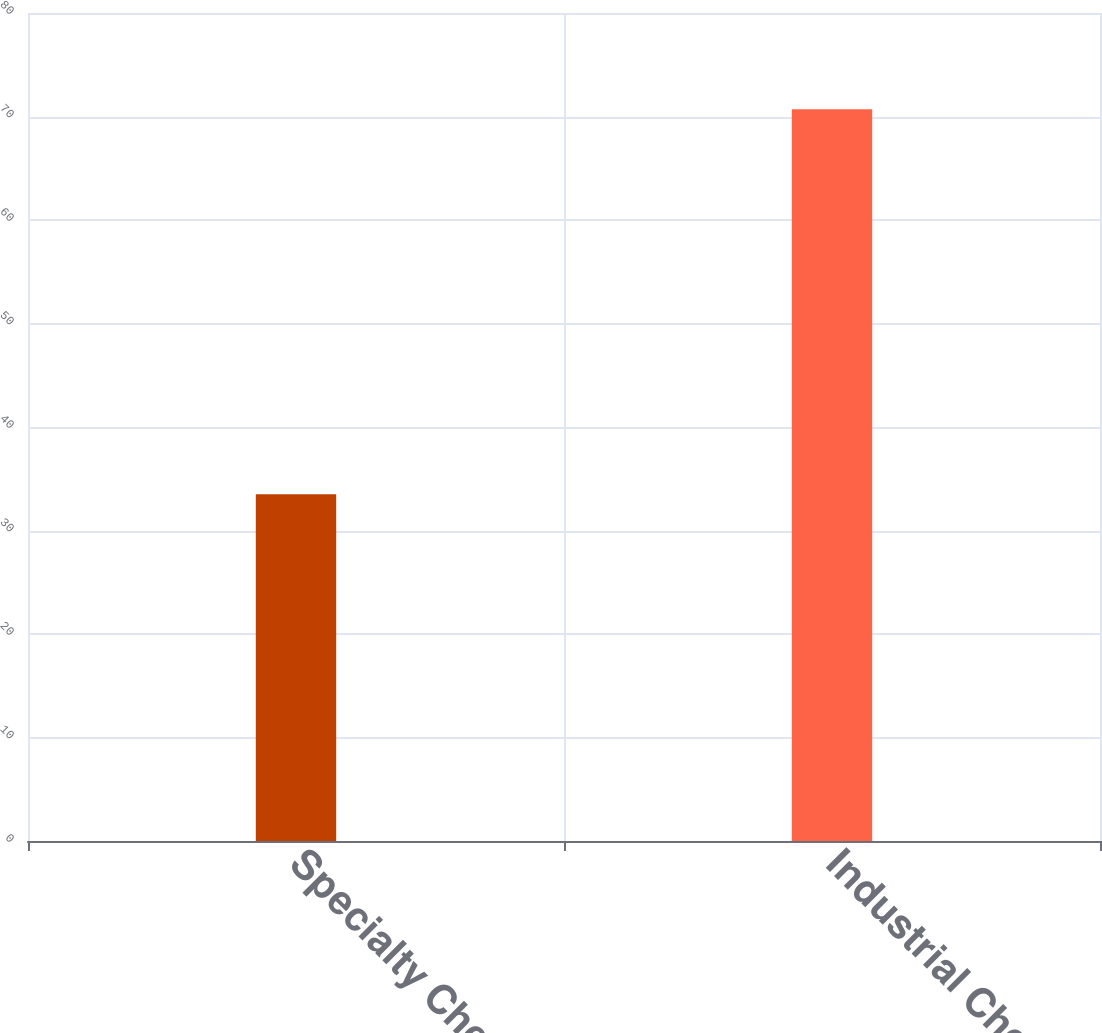Convert chart. <chart><loc_0><loc_0><loc_500><loc_500><bar_chart><fcel>Specialty Chemicals<fcel>Industrial Chemicals<nl><fcel>33.5<fcel>70.7<nl></chart> 